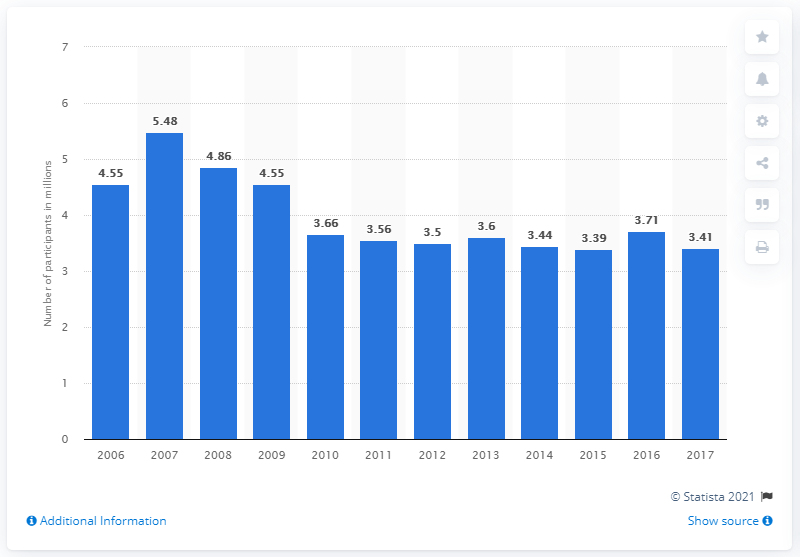Give some essential details in this illustration. In 2017, it is estimated that 3.41 people participated in paintball. 